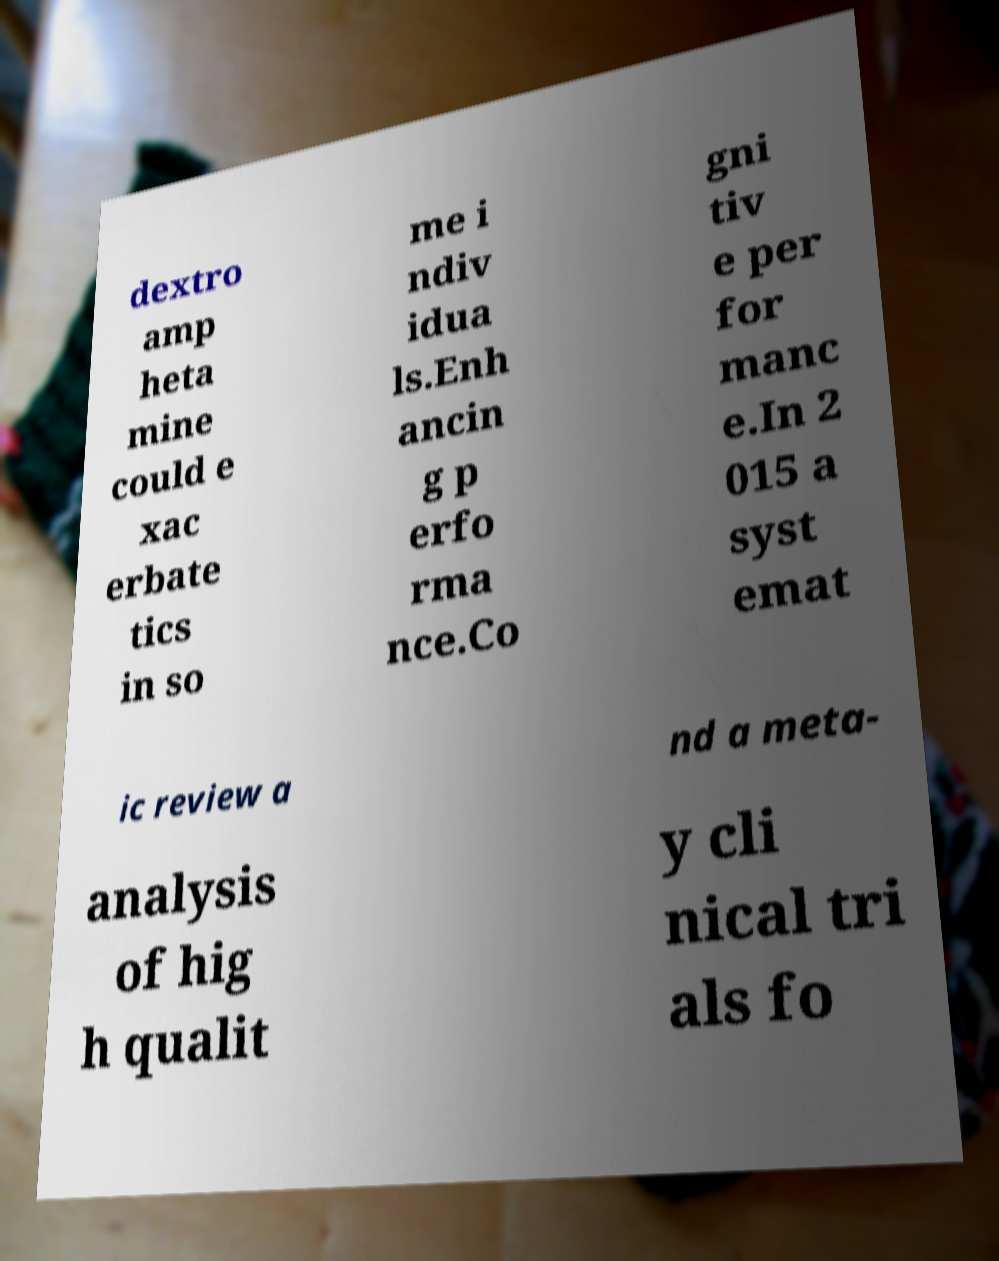For documentation purposes, I need the text within this image transcribed. Could you provide that? dextro amp heta mine could e xac erbate tics in so me i ndiv idua ls.Enh ancin g p erfo rma nce.Co gni tiv e per for manc e.In 2 015 a syst emat ic review a nd a meta- analysis of hig h qualit y cli nical tri als fo 